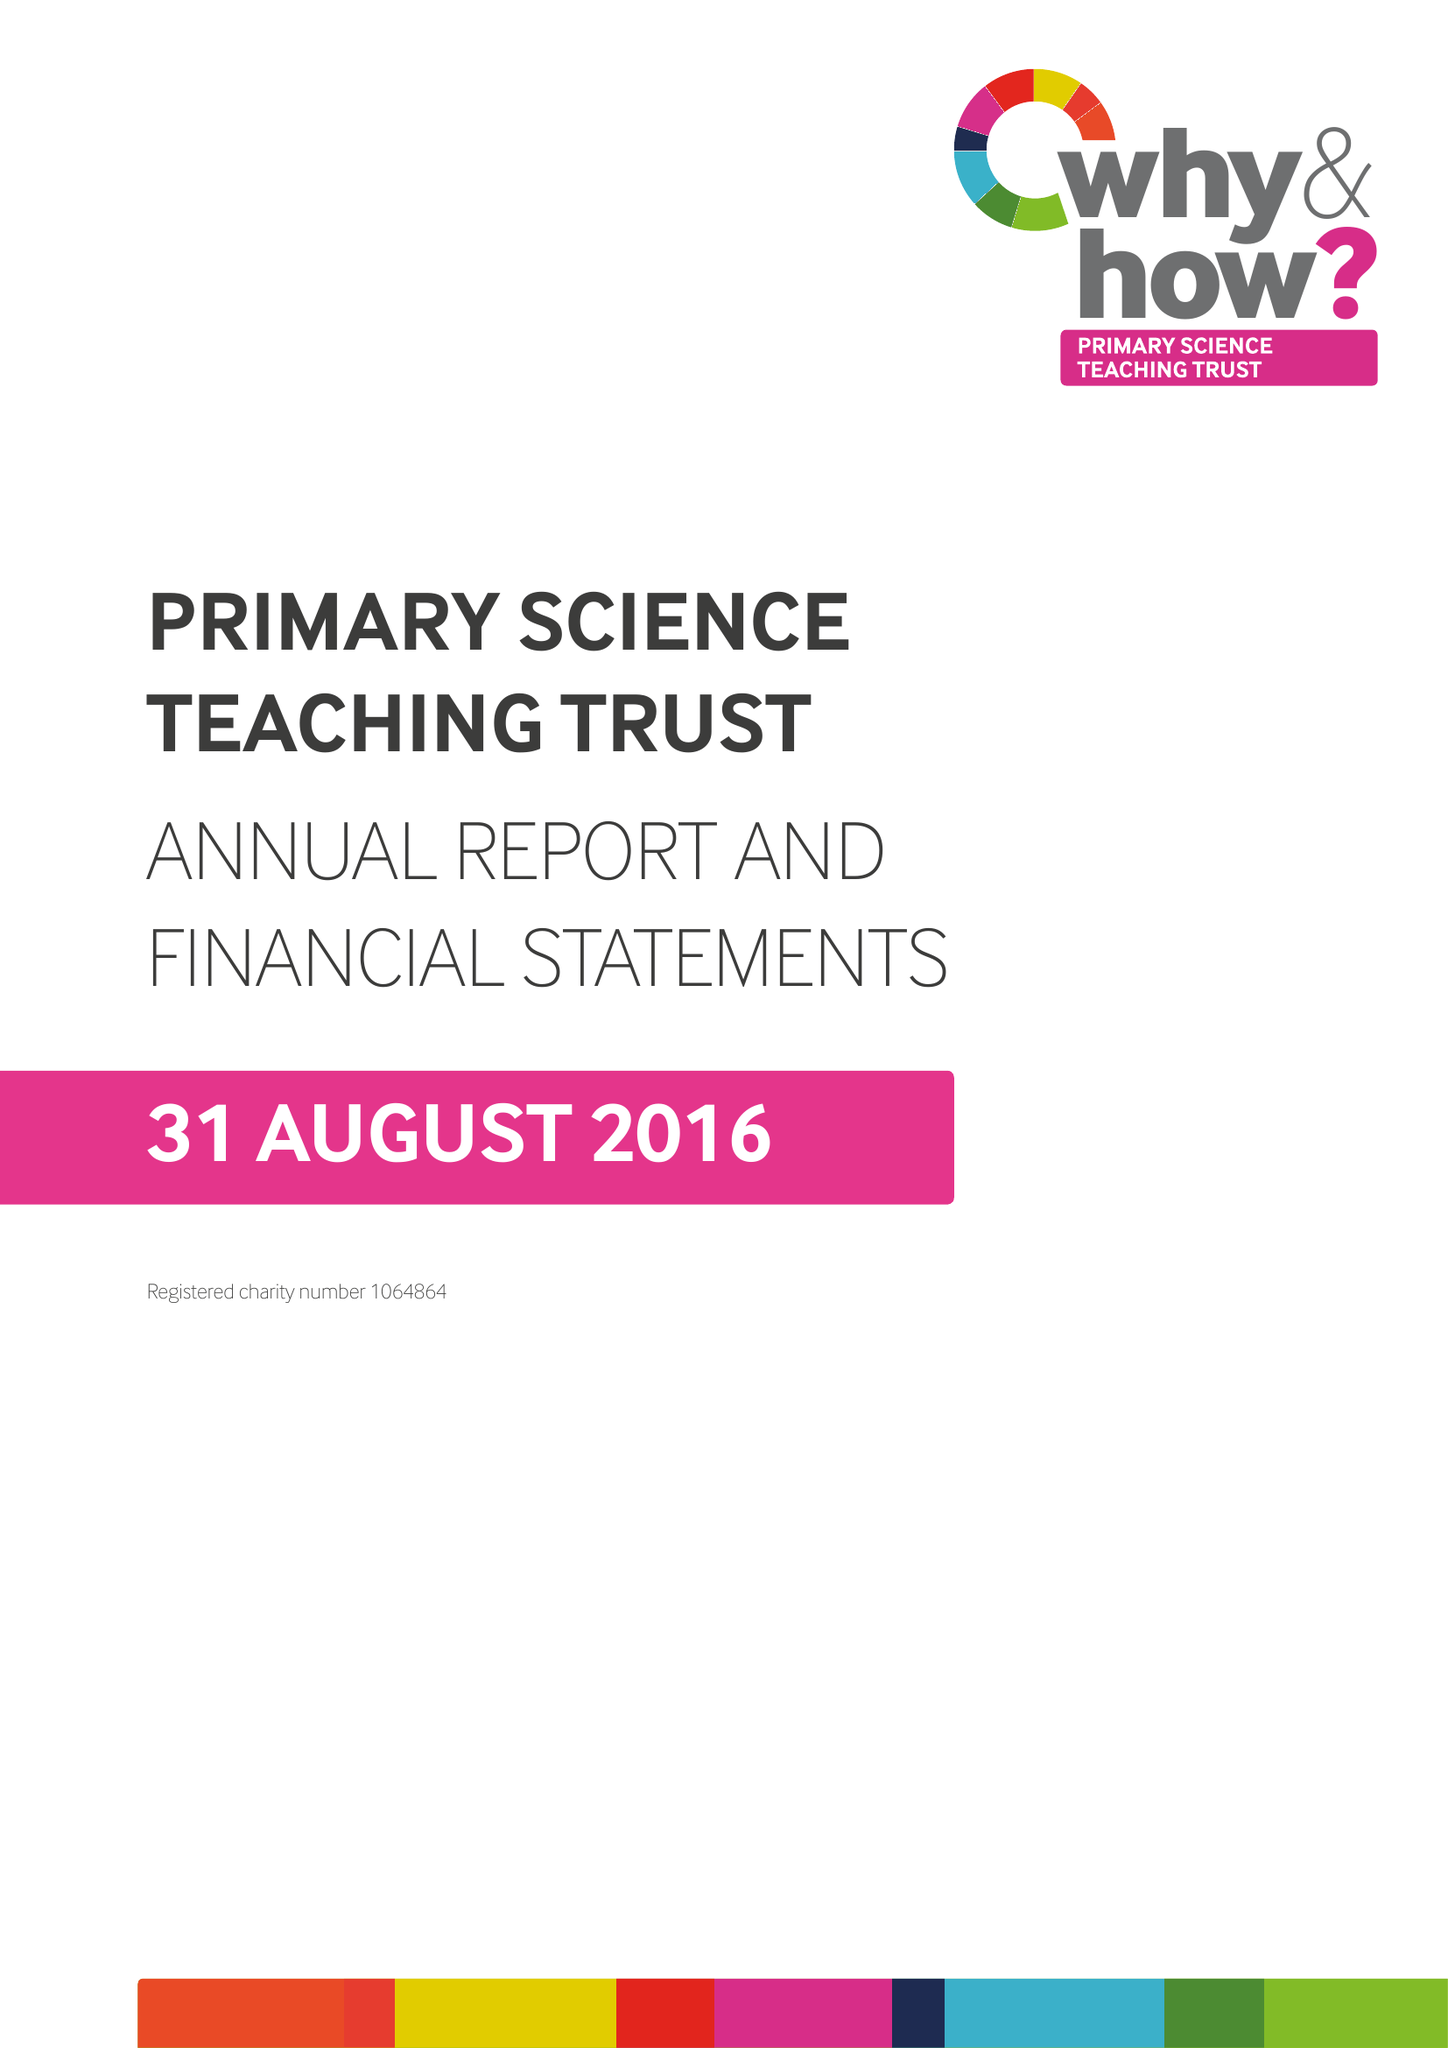What is the value for the address__street_line?
Answer the question using a single word or phrase. None 